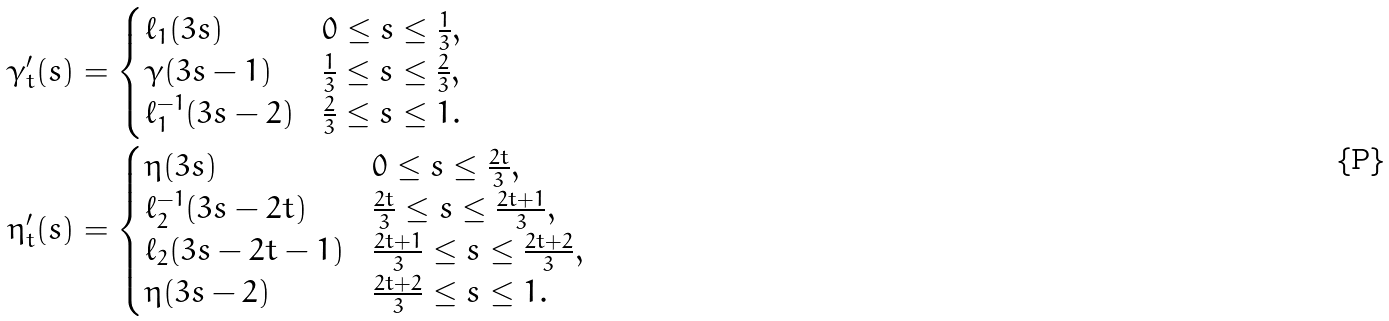<formula> <loc_0><loc_0><loc_500><loc_500>\gamma ^ { \prime } _ { t } ( s ) & = \begin{cases} \ell _ { 1 } ( 3 s ) & 0 \leq s \leq \frac { 1 } { 3 } , \\ \gamma ( 3 s - 1 ) & \frac { 1 } { 3 } \leq s \leq \frac { 2 } { 3 } , \\ \ell _ { 1 } ^ { - 1 } ( 3 s - 2 ) & \frac { 2 } { 3 } \leq s \leq 1 . \end{cases} \\ \eta ^ { \prime } _ { t } ( s ) & = \begin{cases} \eta ( 3 s ) & 0 \leq s \leq \frac { 2 t } 3 , \\ \ell _ { 2 } ^ { - 1 } ( 3 s - 2 t ) & \frac { 2 t } 3 \leq s \leq \frac { 2 t + 1 } 3 , \\ \ell _ { 2 } ( 3 s - 2 t - 1 ) & \frac { 2 t + 1 } 3 \leq s \leq \frac { 2 t + 2 } 3 , \\ \eta ( 3 s - 2 ) & \frac { 2 t + 2 } 3 \leq s \leq 1 . \end{cases}</formula> 